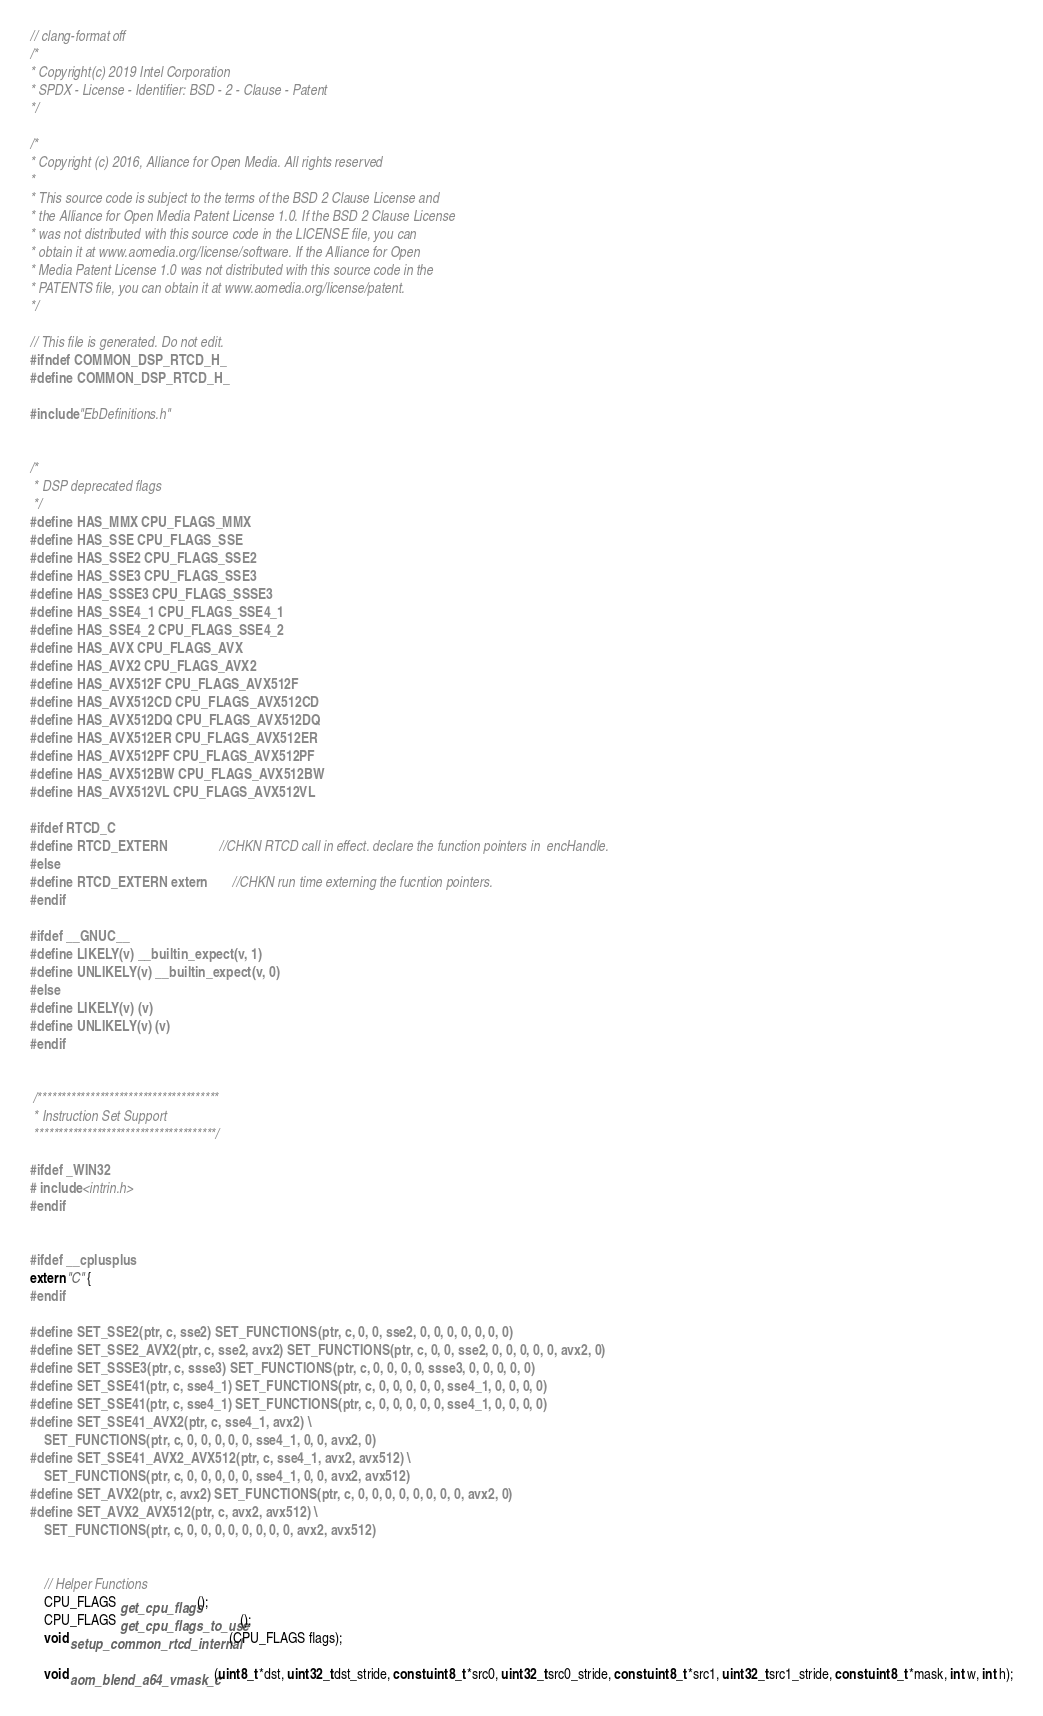<code> <loc_0><loc_0><loc_500><loc_500><_C_>// clang-format off
/*
* Copyright(c) 2019 Intel Corporation
* SPDX - License - Identifier: BSD - 2 - Clause - Patent
*/

/*
* Copyright (c) 2016, Alliance for Open Media. All rights reserved
*
* This source code is subject to the terms of the BSD 2 Clause License and
* the Alliance for Open Media Patent License 1.0. If the BSD 2 Clause License
* was not distributed with this source code in the LICENSE file, you can
* obtain it at www.aomedia.org/license/software. If the Alliance for Open
* Media Patent License 1.0 was not distributed with this source code in the
* PATENTS file, you can obtain it at www.aomedia.org/license/patent.
*/

// This file is generated. Do not edit.
#ifndef COMMON_DSP_RTCD_H_
#define COMMON_DSP_RTCD_H_

#include "EbDefinitions.h"


/*
 * DSP deprecated flags
 */
#define HAS_MMX CPU_FLAGS_MMX
#define HAS_SSE CPU_FLAGS_SSE
#define HAS_SSE2 CPU_FLAGS_SSE2
#define HAS_SSE3 CPU_FLAGS_SSE3
#define HAS_SSSE3 CPU_FLAGS_SSSE3
#define HAS_SSE4_1 CPU_FLAGS_SSE4_1
#define HAS_SSE4_2 CPU_FLAGS_SSE4_2
#define HAS_AVX CPU_FLAGS_AVX
#define HAS_AVX2 CPU_FLAGS_AVX2
#define HAS_AVX512F CPU_FLAGS_AVX512F
#define HAS_AVX512CD CPU_FLAGS_AVX512CD
#define HAS_AVX512DQ CPU_FLAGS_AVX512DQ
#define HAS_AVX512ER CPU_FLAGS_AVX512ER
#define HAS_AVX512PF CPU_FLAGS_AVX512PF
#define HAS_AVX512BW CPU_FLAGS_AVX512BW
#define HAS_AVX512VL CPU_FLAGS_AVX512VL

#ifdef RTCD_C
#define RTCD_EXTERN                //CHKN RTCD call in effect. declare the function pointers in  encHandle.
#else
#define RTCD_EXTERN extern         //CHKN run time externing the fucntion pointers.
#endif

#ifdef __GNUC__
#define LIKELY(v) __builtin_expect(v, 1)
#define UNLIKELY(v) __builtin_expect(v, 0)
#else
#define LIKELY(v) (v)
#define UNLIKELY(v) (v)
#endif


 /**************************************
 * Instruction Set Support
 **************************************/

#ifdef _WIN32
# include <intrin.h>
#endif


#ifdef __cplusplus
extern "C" {
#endif

#define SET_SSE2(ptr, c, sse2) SET_FUNCTIONS(ptr, c, 0, 0, sse2, 0, 0, 0, 0, 0, 0, 0)
#define SET_SSE2_AVX2(ptr, c, sse2, avx2) SET_FUNCTIONS(ptr, c, 0, 0, sse2, 0, 0, 0, 0, 0, avx2, 0)
#define SET_SSSE3(ptr, c, ssse3) SET_FUNCTIONS(ptr, c, 0, 0, 0, 0, ssse3, 0, 0, 0, 0, 0)
#define SET_SSE41(ptr, c, sse4_1) SET_FUNCTIONS(ptr, c, 0, 0, 0, 0, 0, sse4_1, 0, 0, 0, 0)
#define SET_SSE41(ptr, c, sse4_1) SET_FUNCTIONS(ptr, c, 0, 0, 0, 0, 0, sse4_1, 0, 0, 0, 0)
#define SET_SSE41_AVX2(ptr, c, sse4_1, avx2) \
    SET_FUNCTIONS(ptr, c, 0, 0, 0, 0, 0, sse4_1, 0, 0, avx2, 0)
#define SET_SSE41_AVX2_AVX512(ptr, c, sse4_1, avx2, avx512) \
    SET_FUNCTIONS(ptr, c, 0, 0, 0, 0, 0, sse4_1, 0, 0, avx2, avx512)
#define SET_AVX2(ptr, c, avx2) SET_FUNCTIONS(ptr, c, 0, 0, 0, 0, 0, 0, 0, 0, avx2, 0)
#define SET_AVX2_AVX512(ptr, c, avx2, avx512) \
    SET_FUNCTIONS(ptr, c, 0, 0, 0, 0, 0, 0, 0, 0, avx2, avx512)


    // Helper Functions
    CPU_FLAGS get_cpu_flags();
    CPU_FLAGS get_cpu_flags_to_use();
    void setup_common_rtcd_internal(CPU_FLAGS flags);

    void aom_blend_a64_vmask_c(uint8_t *dst, uint32_t dst_stride, const uint8_t *src0, uint32_t src0_stride, const uint8_t *src1, uint32_t src1_stride, const uint8_t *mask, int w, int h);</code> 